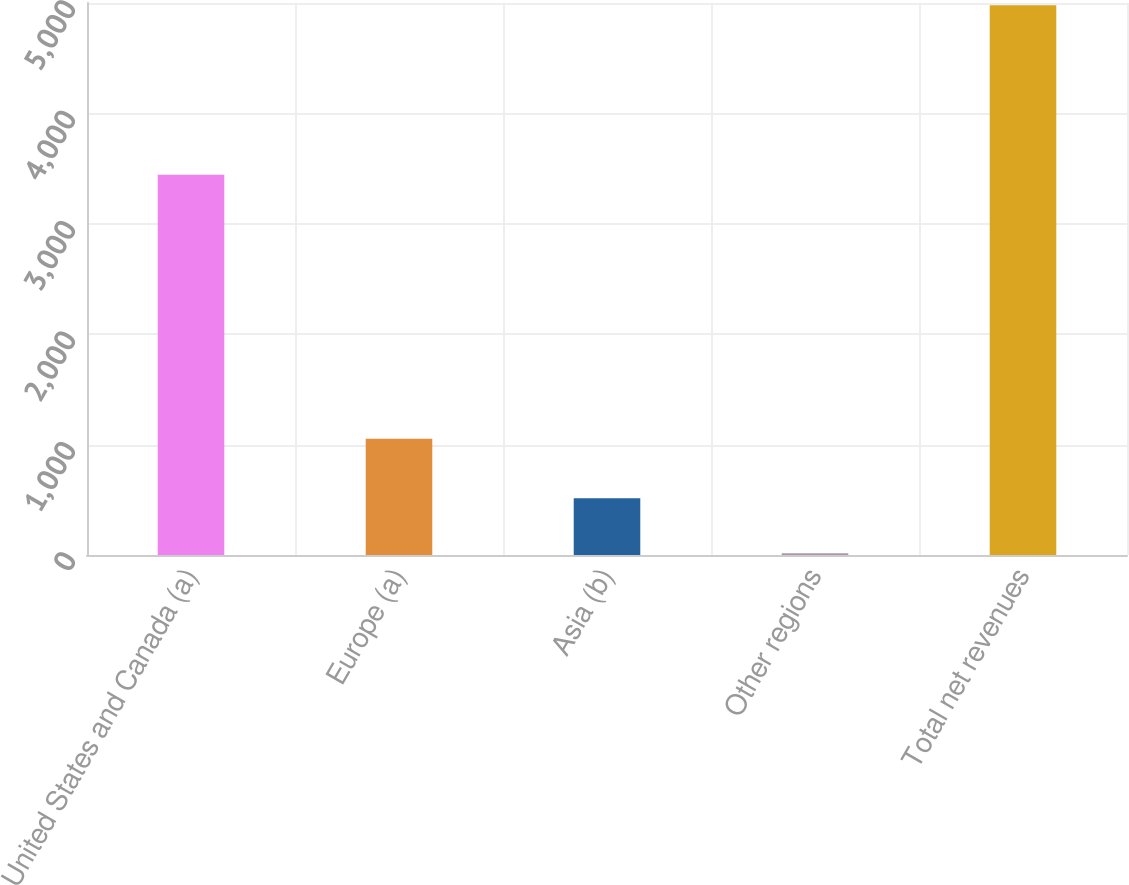<chart> <loc_0><loc_0><loc_500><loc_500><bar_chart><fcel>United States and Canada (a)<fcel>Europe (a)<fcel>Asia (b)<fcel>Other regions<fcel>Total net revenues<nl><fcel>3445.4<fcel>1052.6<fcel>513.01<fcel>16.8<fcel>4978.9<nl></chart> 